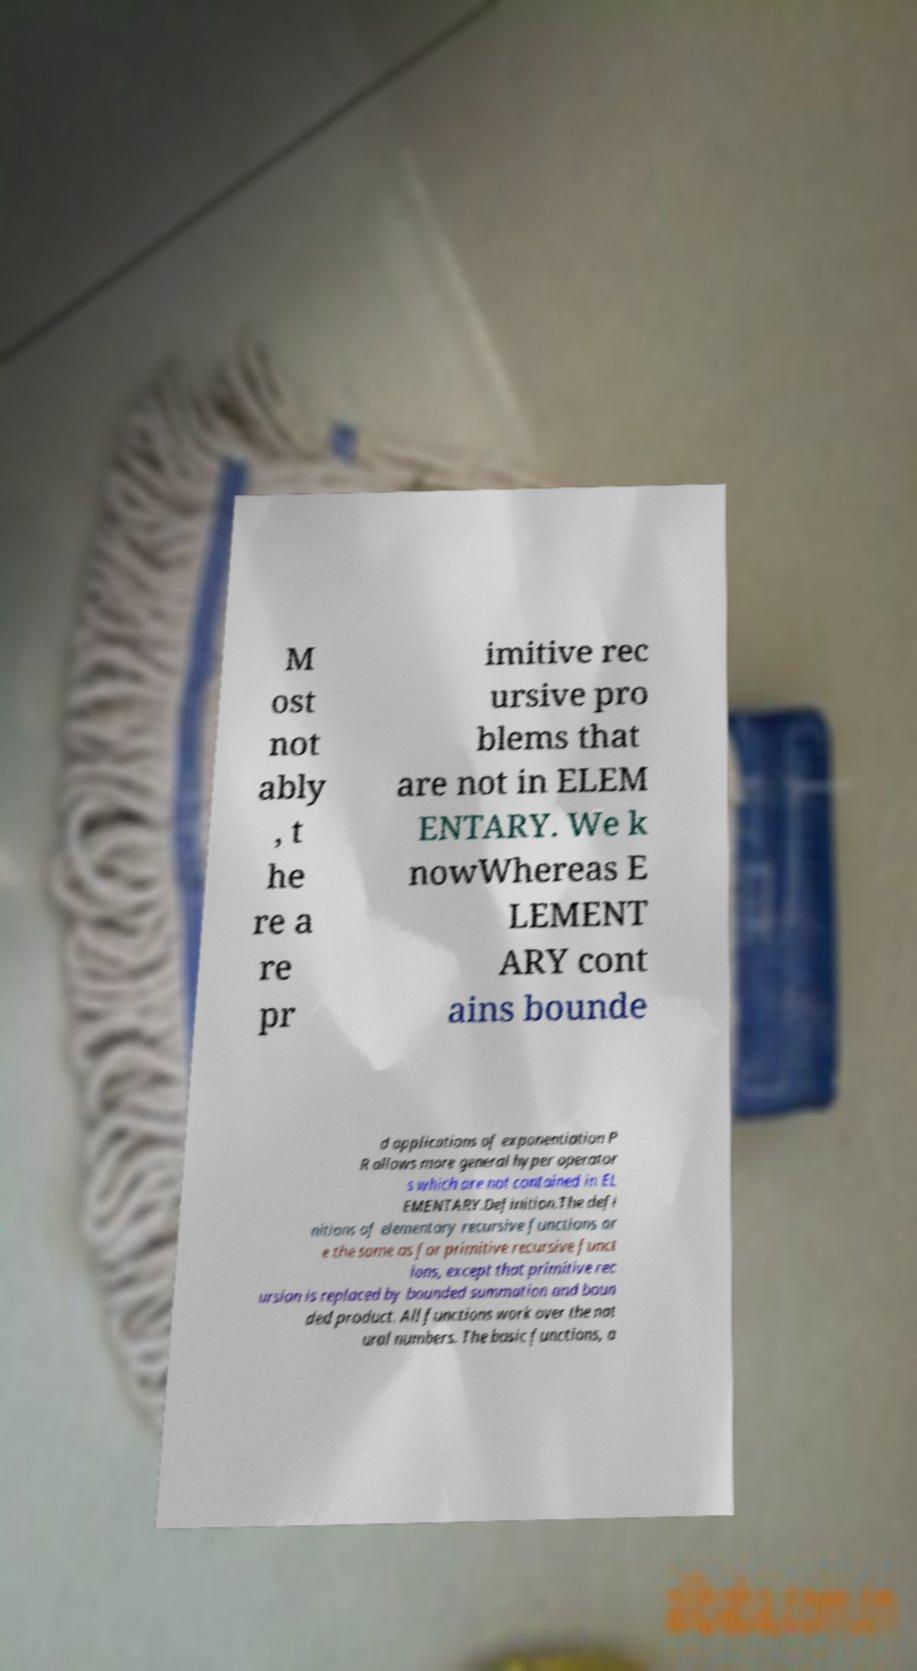Could you extract and type out the text from this image? M ost not ably , t he re a re pr imitive rec ursive pro blems that are not in ELEM ENTARY. We k nowWhereas E LEMENT ARY cont ains bounde d applications of exponentiation P R allows more general hyper operator s which are not contained in EL EMENTARY.Definition.The defi nitions of elementary recursive functions ar e the same as for primitive recursive funct ions, except that primitive rec ursion is replaced by bounded summation and boun ded product. All functions work over the nat ural numbers. The basic functions, a 